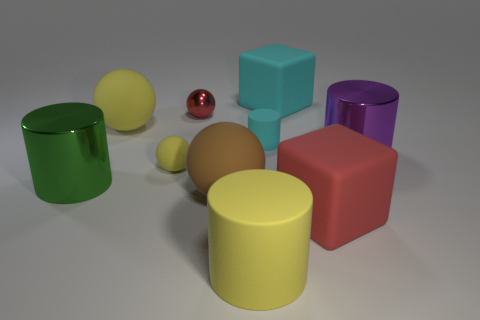What color is the matte cylinder that is the same size as the red matte thing?
Keep it short and to the point. Yellow. Is the size of the green metal cylinder the same as the cube to the right of the cyan cube?
Provide a succinct answer. Yes. How many small spheres have the same color as the large rubber cylinder?
Give a very brief answer. 1. What number of things are small yellow metal cubes or small matte things that are behind the small yellow rubber sphere?
Make the answer very short. 1. Does the matte block in front of the green cylinder have the same size as the cylinder that is on the right side of the big cyan rubber object?
Your answer should be very brief. Yes. Are there any big cylinders made of the same material as the tiny cylinder?
Make the answer very short. Yes. The large cyan thing has what shape?
Offer a terse response. Cube. What is the shape of the cyan matte object that is in front of the large rubber block that is behind the red metal object?
Make the answer very short. Cylinder. How many other things are the same shape as the large brown object?
Offer a very short reply. 3. There is a matte cylinder that is behind the red matte object that is to the right of the brown matte thing; what size is it?
Offer a terse response. Small. 